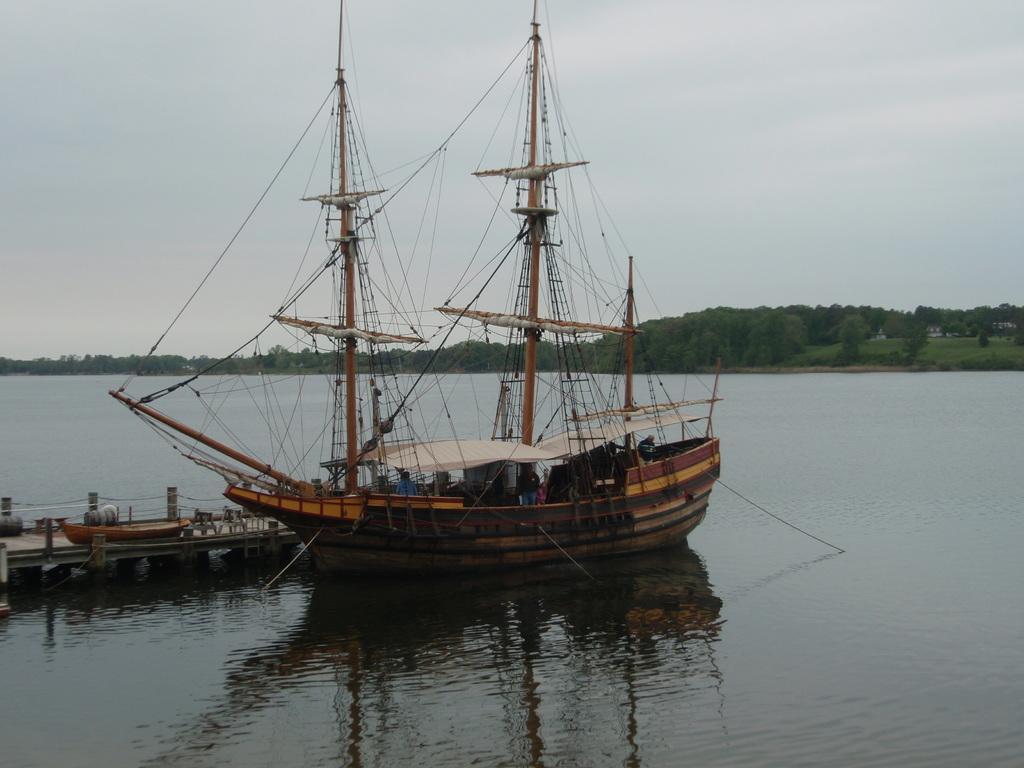Describe this image in one or two sentences. In this picture, it seems like a ship and a dock on the water surface in the foreground, there are trees and the sky in the background. 